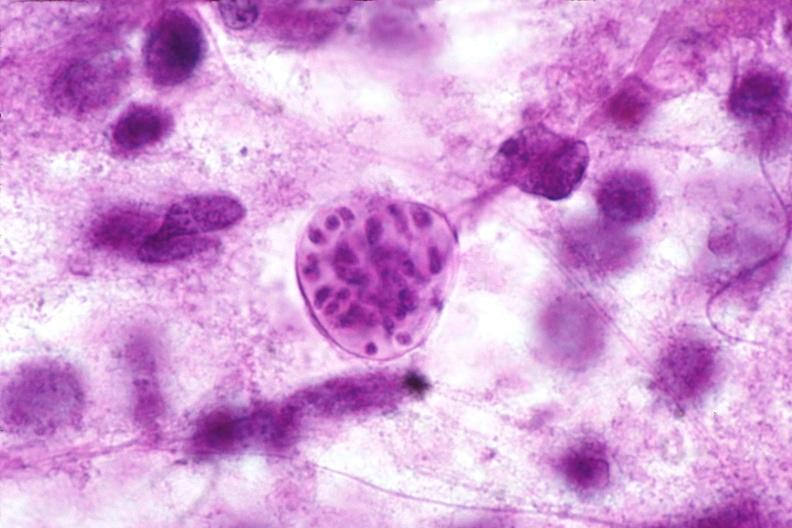what does this image show?
Answer the question using a single word or phrase. Brain 